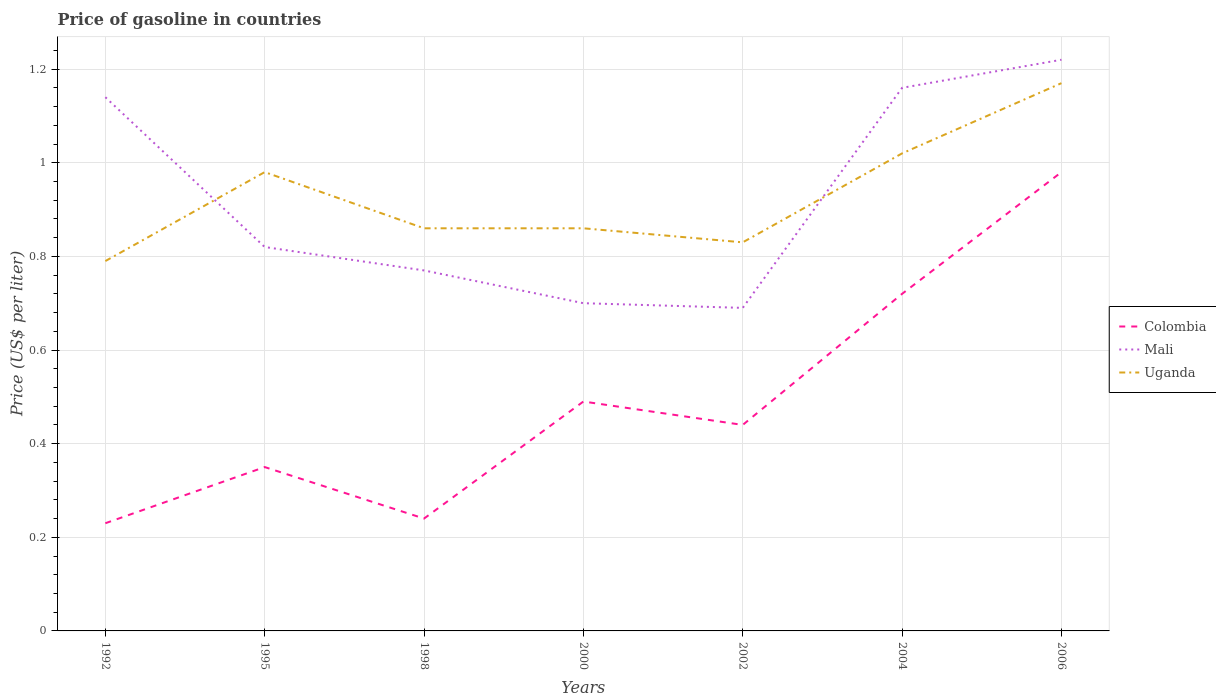How many different coloured lines are there?
Your answer should be compact. 3. Does the line corresponding to Colombia intersect with the line corresponding to Mali?
Your answer should be very brief. No. Is the number of lines equal to the number of legend labels?
Offer a terse response. Yes. Across all years, what is the maximum price of gasoline in Mali?
Offer a very short reply. 0.69. What is the total price of gasoline in Uganda in the graph?
Provide a succinct answer. -0.07. What is the difference between the highest and the second highest price of gasoline in Uganda?
Provide a short and direct response. 0.38. What is the difference between the highest and the lowest price of gasoline in Colombia?
Provide a succinct answer. 2. How many lines are there?
Provide a succinct answer. 3. Does the graph contain any zero values?
Offer a terse response. No. Where does the legend appear in the graph?
Provide a succinct answer. Center right. How are the legend labels stacked?
Make the answer very short. Vertical. What is the title of the graph?
Provide a succinct answer. Price of gasoline in countries. Does "Papua New Guinea" appear as one of the legend labels in the graph?
Ensure brevity in your answer.  No. What is the label or title of the Y-axis?
Ensure brevity in your answer.  Price (US$ per liter). What is the Price (US$ per liter) in Colombia in 1992?
Ensure brevity in your answer.  0.23. What is the Price (US$ per liter) in Mali in 1992?
Your response must be concise. 1.14. What is the Price (US$ per liter) in Uganda in 1992?
Your response must be concise. 0.79. What is the Price (US$ per liter) in Mali in 1995?
Keep it short and to the point. 0.82. What is the Price (US$ per liter) of Colombia in 1998?
Your answer should be very brief. 0.24. What is the Price (US$ per liter) of Mali in 1998?
Ensure brevity in your answer.  0.77. What is the Price (US$ per liter) in Uganda in 1998?
Offer a terse response. 0.86. What is the Price (US$ per liter) of Colombia in 2000?
Offer a terse response. 0.49. What is the Price (US$ per liter) in Uganda in 2000?
Offer a terse response. 0.86. What is the Price (US$ per liter) in Colombia in 2002?
Keep it short and to the point. 0.44. What is the Price (US$ per liter) of Mali in 2002?
Your response must be concise. 0.69. What is the Price (US$ per liter) in Uganda in 2002?
Your response must be concise. 0.83. What is the Price (US$ per liter) in Colombia in 2004?
Make the answer very short. 0.72. What is the Price (US$ per liter) in Mali in 2004?
Make the answer very short. 1.16. What is the Price (US$ per liter) of Uganda in 2004?
Offer a terse response. 1.02. What is the Price (US$ per liter) in Mali in 2006?
Give a very brief answer. 1.22. What is the Price (US$ per liter) in Uganda in 2006?
Provide a short and direct response. 1.17. Across all years, what is the maximum Price (US$ per liter) in Mali?
Keep it short and to the point. 1.22. Across all years, what is the maximum Price (US$ per liter) in Uganda?
Give a very brief answer. 1.17. Across all years, what is the minimum Price (US$ per liter) of Colombia?
Your answer should be compact. 0.23. Across all years, what is the minimum Price (US$ per liter) of Mali?
Your answer should be compact. 0.69. Across all years, what is the minimum Price (US$ per liter) in Uganda?
Your response must be concise. 0.79. What is the total Price (US$ per liter) in Colombia in the graph?
Give a very brief answer. 3.45. What is the total Price (US$ per liter) of Mali in the graph?
Offer a terse response. 6.5. What is the total Price (US$ per liter) of Uganda in the graph?
Offer a terse response. 6.51. What is the difference between the Price (US$ per liter) of Colombia in 1992 and that in 1995?
Your response must be concise. -0.12. What is the difference between the Price (US$ per liter) in Mali in 1992 and that in 1995?
Keep it short and to the point. 0.32. What is the difference between the Price (US$ per liter) in Uganda in 1992 and that in 1995?
Offer a terse response. -0.19. What is the difference between the Price (US$ per liter) of Colombia in 1992 and that in 1998?
Provide a succinct answer. -0.01. What is the difference between the Price (US$ per liter) of Mali in 1992 and that in 1998?
Provide a short and direct response. 0.37. What is the difference between the Price (US$ per liter) of Uganda in 1992 and that in 1998?
Provide a short and direct response. -0.07. What is the difference between the Price (US$ per liter) of Colombia in 1992 and that in 2000?
Make the answer very short. -0.26. What is the difference between the Price (US$ per liter) in Mali in 1992 and that in 2000?
Make the answer very short. 0.44. What is the difference between the Price (US$ per liter) in Uganda in 1992 and that in 2000?
Your response must be concise. -0.07. What is the difference between the Price (US$ per liter) in Colombia in 1992 and that in 2002?
Your answer should be compact. -0.21. What is the difference between the Price (US$ per liter) in Mali in 1992 and that in 2002?
Give a very brief answer. 0.45. What is the difference between the Price (US$ per liter) of Uganda in 1992 and that in 2002?
Provide a succinct answer. -0.04. What is the difference between the Price (US$ per liter) of Colombia in 1992 and that in 2004?
Ensure brevity in your answer.  -0.49. What is the difference between the Price (US$ per liter) in Mali in 1992 and that in 2004?
Provide a short and direct response. -0.02. What is the difference between the Price (US$ per liter) of Uganda in 1992 and that in 2004?
Your answer should be very brief. -0.23. What is the difference between the Price (US$ per liter) of Colombia in 1992 and that in 2006?
Make the answer very short. -0.75. What is the difference between the Price (US$ per liter) of Mali in 1992 and that in 2006?
Ensure brevity in your answer.  -0.08. What is the difference between the Price (US$ per liter) of Uganda in 1992 and that in 2006?
Give a very brief answer. -0.38. What is the difference between the Price (US$ per liter) in Colombia in 1995 and that in 1998?
Ensure brevity in your answer.  0.11. What is the difference between the Price (US$ per liter) in Mali in 1995 and that in 1998?
Offer a very short reply. 0.05. What is the difference between the Price (US$ per liter) in Uganda in 1995 and that in 1998?
Offer a very short reply. 0.12. What is the difference between the Price (US$ per liter) of Colombia in 1995 and that in 2000?
Offer a terse response. -0.14. What is the difference between the Price (US$ per liter) in Mali in 1995 and that in 2000?
Offer a very short reply. 0.12. What is the difference between the Price (US$ per liter) in Uganda in 1995 and that in 2000?
Keep it short and to the point. 0.12. What is the difference between the Price (US$ per liter) of Colombia in 1995 and that in 2002?
Your response must be concise. -0.09. What is the difference between the Price (US$ per liter) in Mali in 1995 and that in 2002?
Make the answer very short. 0.13. What is the difference between the Price (US$ per liter) of Colombia in 1995 and that in 2004?
Provide a succinct answer. -0.37. What is the difference between the Price (US$ per liter) in Mali in 1995 and that in 2004?
Provide a succinct answer. -0.34. What is the difference between the Price (US$ per liter) in Uganda in 1995 and that in 2004?
Provide a short and direct response. -0.04. What is the difference between the Price (US$ per liter) of Colombia in 1995 and that in 2006?
Give a very brief answer. -0.63. What is the difference between the Price (US$ per liter) of Mali in 1995 and that in 2006?
Make the answer very short. -0.4. What is the difference between the Price (US$ per liter) in Uganda in 1995 and that in 2006?
Ensure brevity in your answer.  -0.19. What is the difference between the Price (US$ per liter) in Mali in 1998 and that in 2000?
Provide a short and direct response. 0.07. What is the difference between the Price (US$ per liter) in Uganda in 1998 and that in 2000?
Provide a short and direct response. 0. What is the difference between the Price (US$ per liter) in Colombia in 1998 and that in 2002?
Keep it short and to the point. -0.2. What is the difference between the Price (US$ per liter) of Mali in 1998 and that in 2002?
Offer a very short reply. 0.08. What is the difference between the Price (US$ per liter) of Colombia in 1998 and that in 2004?
Your answer should be compact. -0.48. What is the difference between the Price (US$ per liter) in Mali in 1998 and that in 2004?
Make the answer very short. -0.39. What is the difference between the Price (US$ per liter) in Uganda in 1998 and that in 2004?
Keep it short and to the point. -0.16. What is the difference between the Price (US$ per liter) in Colombia in 1998 and that in 2006?
Give a very brief answer. -0.74. What is the difference between the Price (US$ per liter) in Mali in 1998 and that in 2006?
Provide a short and direct response. -0.45. What is the difference between the Price (US$ per liter) of Uganda in 1998 and that in 2006?
Offer a terse response. -0.31. What is the difference between the Price (US$ per liter) of Colombia in 2000 and that in 2002?
Provide a succinct answer. 0.05. What is the difference between the Price (US$ per liter) of Uganda in 2000 and that in 2002?
Provide a short and direct response. 0.03. What is the difference between the Price (US$ per liter) of Colombia in 2000 and that in 2004?
Provide a short and direct response. -0.23. What is the difference between the Price (US$ per liter) of Mali in 2000 and that in 2004?
Ensure brevity in your answer.  -0.46. What is the difference between the Price (US$ per liter) of Uganda in 2000 and that in 2004?
Your response must be concise. -0.16. What is the difference between the Price (US$ per liter) in Colombia in 2000 and that in 2006?
Provide a succinct answer. -0.49. What is the difference between the Price (US$ per liter) of Mali in 2000 and that in 2006?
Keep it short and to the point. -0.52. What is the difference between the Price (US$ per liter) in Uganda in 2000 and that in 2006?
Give a very brief answer. -0.31. What is the difference between the Price (US$ per liter) in Colombia in 2002 and that in 2004?
Ensure brevity in your answer.  -0.28. What is the difference between the Price (US$ per liter) in Mali in 2002 and that in 2004?
Offer a terse response. -0.47. What is the difference between the Price (US$ per liter) in Uganda in 2002 and that in 2004?
Give a very brief answer. -0.19. What is the difference between the Price (US$ per liter) in Colombia in 2002 and that in 2006?
Your answer should be very brief. -0.54. What is the difference between the Price (US$ per liter) of Mali in 2002 and that in 2006?
Provide a succinct answer. -0.53. What is the difference between the Price (US$ per liter) of Uganda in 2002 and that in 2006?
Offer a very short reply. -0.34. What is the difference between the Price (US$ per liter) of Colombia in 2004 and that in 2006?
Offer a terse response. -0.26. What is the difference between the Price (US$ per liter) in Mali in 2004 and that in 2006?
Provide a short and direct response. -0.06. What is the difference between the Price (US$ per liter) of Uganda in 2004 and that in 2006?
Provide a succinct answer. -0.15. What is the difference between the Price (US$ per liter) of Colombia in 1992 and the Price (US$ per liter) of Mali in 1995?
Your answer should be compact. -0.59. What is the difference between the Price (US$ per liter) in Colombia in 1992 and the Price (US$ per liter) in Uganda in 1995?
Keep it short and to the point. -0.75. What is the difference between the Price (US$ per liter) in Mali in 1992 and the Price (US$ per liter) in Uganda in 1995?
Provide a short and direct response. 0.16. What is the difference between the Price (US$ per liter) of Colombia in 1992 and the Price (US$ per liter) of Mali in 1998?
Keep it short and to the point. -0.54. What is the difference between the Price (US$ per liter) in Colombia in 1992 and the Price (US$ per liter) in Uganda in 1998?
Give a very brief answer. -0.63. What is the difference between the Price (US$ per liter) of Mali in 1992 and the Price (US$ per liter) of Uganda in 1998?
Ensure brevity in your answer.  0.28. What is the difference between the Price (US$ per liter) in Colombia in 1992 and the Price (US$ per liter) in Mali in 2000?
Give a very brief answer. -0.47. What is the difference between the Price (US$ per liter) in Colombia in 1992 and the Price (US$ per liter) in Uganda in 2000?
Your response must be concise. -0.63. What is the difference between the Price (US$ per liter) of Mali in 1992 and the Price (US$ per liter) of Uganda in 2000?
Provide a succinct answer. 0.28. What is the difference between the Price (US$ per liter) in Colombia in 1992 and the Price (US$ per liter) in Mali in 2002?
Your response must be concise. -0.46. What is the difference between the Price (US$ per liter) of Mali in 1992 and the Price (US$ per liter) of Uganda in 2002?
Give a very brief answer. 0.31. What is the difference between the Price (US$ per liter) in Colombia in 1992 and the Price (US$ per liter) in Mali in 2004?
Offer a terse response. -0.93. What is the difference between the Price (US$ per liter) in Colombia in 1992 and the Price (US$ per liter) in Uganda in 2004?
Your response must be concise. -0.79. What is the difference between the Price (US$ per liter) of Mali in 1992 and the Price (US$ per liter) of Uganda in 2004?
Your answer should be very brief. 0.12. What is the difference between the Price (US$ per liter) in Colombia in 1992 and the Price (US$ per liter) in Mali in 2006?
Give a very brief answer. -0.99. What is the difference between the Price (US$ per liter) of Colombia in 1992 and the Price (US$ per liter) of Uganda in 2006?
Your answer should be very brief. -0.94. What is the difference between the Price (US$ per liter) in Mali in 1992 and the Price (US$ per liter) in Uganda in 2006?
Make the answer very short. -0.03. What is the difference between the Price (US$ per liter) of Colombia in 1995 and the Price (US$ per liter) of Mali in 1998?
Offer a very short reply. -0.42. What is the difference between the Price (US$ per liter) of Colombia in 1995 and the Price (US$ per liter) of Uganda in 1998?
Provide a succinct answer. -0.51. What is the difference between the Price (US$ per liter) in Mali in 1995 and the Price (US$ per liter) in Uganda in 1998?
Ensure brevity in your answer.  -0.04. What is the difference between the Price (US$ per liter) of Colombia in 1995 and the Price (US$ per liter) of Mali in 2000?
Provide a short and direct response. -0.35. What is the difference between the Price (US$ per liter) of Colombia in 1995 and the Price (US$ per liter) of Uganda in 2000?
Provide a short and direct response. -0.51. What is the difference between the Price (US$ per liter) in Mali in 1995 and the Price (US$ per liter) in Uganda in 2000?
Ensure brevity in your answer.  -0.04. What is the difference between the Price (US$ per liter) in Colombia in 1995 and the Price (US$ per liter) in Mali in 2002?
Provide a succinct answer. -0.34. What is the difference between the Price (US$ per liter) of Colombia in 1995 and the Price (US$ per liter) of Uganda in 2002?
Offer a very short reply. -0.48. What is the difference between the Price (US$ per liter) of Mali in 1995 and the Price (US$ per liter) of Uganda in 2002?
Keep it short and to the point. -0.01. What is the difference between the Price (US$ per liter) of Colombia in 1995 and the Price (US$ per liter) of Mali in 2004?
Give a very brief answer. -0.81. What is the difference between the Price (US$ per liter) of Colombia in 1995 and the Price (US$ per liter) of Uganda in 2004?
Your answer should be compact. -0.67. What is the difference between the Price (US$ per liter) in Mali in 1995 and the Price (US$ per liter) in Uganda in 2004?
Your answer should be compact. -0.2. What is the difference between the Price (US$ per liter) of Colombia in 1995 and the Price (US$ per liter) of Mali in 2006?
Provide a succinct answer. -0.87. What is the difference between the Price (US$ per liter) of Colombia in 1995 and the Price (US$ per liter) of Uganda in 2006?
Your answer should be very brief. -0.82. What is the difference between the Price (US$ per liter) of Mali in 1995 and the Price (US$ per liter) of Uganda in 2006?
Provide a succinct answer. -0.35. What is the difference between the Price (US$ per liter) in Colombia in 1998 and the Price (US$ per liter) in Mali in 2000?
Make the answer very short. -0.46. What is the difference between the Price (US$ per liter) of Colombia in 1998 and the Price (US$ per liter) of Uganda in 2000?
Provide a succinct answer. -0.62. What is the difference between the Price (US$ per liter) in Mali in 1998 and the Price (US$ per liter) in Uganda in 2000?
Offer a terse response. -0.09. What is the difference between the Price (US$ per liter) of Colombia in 1998 and the Price (US$ per liter) of Mali in 2002?
Your answer should be compact. -0.45. What is the difference between the Price (US$ per liter) of Colombia in 1998 and the Price (US$ per liter) of Uganda in 2002?
Your response must be concise. -0.59. What is the difference between the Price (US$ per liter) in Mali in 1998 and the Price (US$ per liter) in Uganda in 2002?
Offer a very short reply. -0.06. What is the difference between the Price (US$ per liter) of Colombia in 1998 and the Price (US$ per liter) of Mali in 2004?
Your answer should be very brief. -0.92. What is the difference between the Price (US$ per liter) of Colombia in 1998 and the Price (US$ per liter) of Uganda in 2004?
Ensure brevity in your answer.  -0.78. What is the difference between the Price (US$ per liter) in Colombia in 1998 and the Price (US$ per liter) in Mali in 2006?
Make the answer very short. -0.98. What is the difference between the Price (US$ per liter) of Colombia in 1998 and the Price (US$ per liter) of Uganda in 2006?
Your response must be concise. -0.93. What is the difference between the Price (US$ per liter) of Colombia in 2000 and the Price (US$ per liter) of Mali in 2002?
Offer a very short reply. -0.2. What is the difference between the Price (US$ per liter) of Colombia in 2000 and the Price (US$ per liter) of Uganda in 2002?
Ensure brevity in your answer.  -0.34. What is the difference between the Price (US$ per liter) in Mali in 2000 and the Price (US$ per liter) in Uganda in 2002?
Keep it short and to the point. -0.13. What is the difference between the Price (US$ per liter) of Colombia in 2000 and the Price (US$ per liter) of Mali in 2004?
Provide a short and direct response. -0.67. What is the difference between the Price (US$ per liter) in Colombia in 2000 and the Price (US$ per liter) in Uganda in 2004?
Keep it short and to the point. -0.53. What is the difference between the Price (US$ per liter) of Mali in 2000 and the Price (US$ per liter) of Uganda in 2004?
Provide a succinct answer. -0.32. What is the difference between the Price (US$ per liter) of Colombia in 2000 and the Price (US$ per liter) of Mali in 2006?
Offer a terse response. -0.73. What is the difference between the Price (US$ per liter) in Colombia in 2000 and the Price (US$ per liter) in Uganda in 2006?
Ensure brevity in your answer.  -0.68. What is the difference between the Price (US$ per liter) in Mali in 2000 and the Price (US$ per liter) in Uganda in 2006?
Keep it short and to the point. -0.47. What is the difference between the Price (US$ per liter) in Colombia in 2002 and the Price (US$ per liter) in Mali in 2004?
Your answer should be very brief. -0.72. What is the difference between the Price (US$ per liter) in Colombia in 2002 and the Price (US$ per liter) in Uganda in 2004?
Offer a terse response. -0.58. What is the difference between the Price (US$ per liter) of Mali in 2002 and the Price (US$ per liter) of Uganda in 2004?
Provide a short and direct response. -0.33. What is the difference between the Price (US$ per liter) in Colombia in 2002 and the Price (US$ per liter) in Mali in 2006?
Ensure brevity in your answer.  -0.78. What is the difference between the Price (US$ per liter) of Colombia in 2002 and the Price (US$ per liter) of Uganda in 2006?
Keep it short and to the point. -0.73. What is the difference between the Price (US$ per liter) in Mali in 2002 and the Price (US$ per liter) in Uganda in 2006?
Provide a succinct answer. -0.48. What is the difference between the Price (US$ per liter) in Colombia in 2004 and the Price (US$ per liter) in Uganda in 2006?
Provide a succinct answer. -0.45. What is the difference between the Price (US$ per liter) in Mali in 2004 and the Price (US$ per liter) in Uganda in 2006?
Your answer should be compact. -0.01. What is the average Price (US$ per liter) of Colombia per year?
Offer a terse response. 0.49. What is the average Price (US$ per liter) of Uganda per year?
Offer a very short reply. 0.93. In the year 1992, what is the difference between the Price (US$ per liter) in Colombia and Price (US$ per liter) in Mali?
Make the answer very short. -0.91. In the year 1992, what is the difference between the Price (US$ per liter) in Colombia and Price (US$ per liter) in Uganda?
Keep it short and to the point. -0.56. In the year 1995, what is the difference between the Price (US$ per liter) in Colombia and Price (US$ per liter) in Mali?
Make the answer very short. -0.47. In the year 1995, what is the difference between the Price (US$ per liter) in Colombia and Price (US$ per liter) in Uganda?
Provide a short and direct response. -0.63. In the year 1995, what is the difference between the Price (US$ per liter) of Mali and Price (US$ per liter) of Uganda?
Keep it short and to the point. -0.16. In the year 1998, what is the difference between the Price (US$ per liter) in Colombia and Price (US$ per liter) in Mali?
Give a very brief answer. -0.53. In the year 1998, what is the difference between the Price (US$ per liter) in Colombia and Price (US$ per liter) in Uganda?
Provide a short and direct response. -0.62. In the year 1998, what is the difference between the Price (US$ per liter) of Mali and Price (US$ per liter) of Uganda?
Offer a very short reply. -0.09. In the year 2000, what is the difference between the Price (US$ per liter) in Colombia and Price (US$ per liter) in Mali?
Offer a very short reply. -0.21. In the year 2000, what is the difference between the Price (US$ per liter) in Colombia and Price (US$ per liter) in Uganda?
Offer a terse response. -0.37. In the year 2000, what is the difference between the Price (US$ per liter) of Mali and Price (US$ per liter) of Uganda?
Your answer should be very brief. -0.16. In the year 2002, what is the difference between the Price (US$ per liter) in Colombia and Price (US$ per liter) in Mali?
Give a very brief answer. -0.25. In the year 2002, what is the difference between the Price (US$ per liter) in Colombia and Price (US$ per liter) in Uganda?
Your answer should be very brief. -0.39. In the year 2002, what is the difference between the Price (US$ per liter) in Mali and Price (US$ per liter) in Uganda?
Keep it short and to the point. -0.14. In the year 2004, what is the difference between the Price (US$ per liter) in Colombia and Price (US$ per liter) in Mali?
Provide a short and direct response. -0.44. In the year 2004, what is the difference between the Price (US$ per liter) of Colombia and Price (US$ per liter) of Uganda?
Offer a very short reply. -0.3. In the year 2004, what is the difference between the Price (US$ per liter) of Mali and Price (US$ per liter) of Uganda?
Your answer should be very brief. 0.14. In the year 2006, what is the difference between the Price (US$ per liter) in Colombia and Price (US$ per liter) in Mali?
Keep it short and to the point. -0.24. In the year 2006, what is the difference between the Price (US$ per liter) in Colombia and Price (US$ per liter) in Uganda?
Provide a short and direct response. -0.19. In the year 2006, what is the difference between the Price (US$ per liter) of Mali and Price (US$ per liter) of Uganda?
Your answer should be compact. 0.05. What is the ratio of the Price (US$ per liter) in Colombia in 1992 to that in 1995?
Keep it short and to the point. 0.66. What is the ratio of the Price (US$ per liter) in Mali in 1992 to that in 1995?
Provide a short and direct response. 1.39. What is the ratio of the Price (US$ per liter) in Uganda in 1992 to that in 1995?
Your answer should be very brief. 0.81. What is the ratio of the Price (US$ per liter) in Mali in 1992 to that in 1998?
Keep it short and to the point. 1.48. What is the ratio of the Price (US$ per liter) of Uganda in 1992 to that in 1998?
Your answer should be compact. 0.92. What is the ratio of the Price (US$ per liter) of Colombia in 1992 to that in 2000?
Your answer should be compact. 0.47. What is the ratio of the Price (US$ per liter) in Mali in 1992 to that in 2000?
Your response must be concise. 1.63. What is the ratio of the Price (US$ per liter) of Uganda in 1992 to that in 2000?
Your answer should be compact. 0.92. What is the ratio of the Price (US$ per liter) of Colombia in 1992 to that in 2002?
Your response must be concise. 0.52. What is the ratio of the Price (US$ per liter) of Mali in 1992 to that in 2002?
Keep it short and to the point. 1.65. What is the ratio of the Price (US$ per liter) of Uganda in 1992 to that in 2002?
Give a very brief answer. 0.95. What is the ratio of the Price (US$ per liter) in Colombia in 1992 to that in 2004?
Ensure brevity in your answer.  0.32. What is the ratio of the Price (US$ per liter) in Mali in 1992 to that in 2004?
Offer a terse response. 0.98. What is the ratio of the Price (US$ per liter) of Uganda in 1992 to that in 2004?
Give a very brief answer. 0.77. What is the ratio of the Price (US$ per liter) in Colombia in 1992 to that in 2006?
Provide a succinct answer. 0.23. What is the ratio of the Price (US$ per liter) in Mali in 1992 to that in 2006?
Your answer should be very brief. 0.93. What is the ratio of the Price (US$ per liter) in Uganda in 1992 to that in 2006?
Offer a very short reply. 0.68. What is the ratio of the Price (US$ per liter) in Colombia in 1995 to that in 1998?
Provide a succinct answer. 1.46. What is the ratio of the Price (US$ per liter) of Mali in 1995 to that in 1998?
Provide a succinct answer. 1.06. What is the ratio of the Price (US$ per liter) in Uganda in 1995 to that in 1998?
Your answer should be compact. 1.14. What is the ratio of the Price (US$ per liter) in Mali in 1995 to that in 2000?
Your response must be concise. 1.17. What is the ratio of the Price (US$ per liter) of Uganda in 1995 to that in 2000?
Give a very brief answer. 1.14. What is the ratio of the Price (US$ per liter) of Colombia in 1995 to that in 2002?
Ensure brevity in your answer.  0.8. What is the ratio of the Price (US$ per liter) in Mali in 1995 to that in 2002?
Make the answer very short. 1.19. What is the ratio of the Price (US$ per liter) in Uganda in 1995 to that in 2002?
Keep it short and to the point. 1.18. What is the ratio of the Price (US$ per liter) in Colombia in 1995 to that in 2004?
Your answer should be very brief. 0.49. What is the ratio of the Price (US$ per liter) of Mali in 1995 to that in 2004?
Give a very brief answer. 0.71. What is the ratio of the Price (US$ per liter) of Uganda in 1995 to that in 2004?
Ensure brevity in your answer.  0.96. What is the ratio of the Price (US$ per liter) of Colombia in 1995 to that in 2006?
Ensure brevity in your answer.  0.36. What is the ratio of the Price (US$ per liter) in Mali in 1995 to that in 2006?
Keep it short and to the point. 0.67. What is the ratio of the Price (US$ per liter) in Uganda in 1995 to that in 2006?
Provide a succinct answer. 0.84. What is the ratio of the Price (US$ per liter) of Colombia in 1998 to that in 2000?
Make the answer very short. 0.49. What is the ratio of the Price (US$ per liter) in Colombia in 1998 to that in 2002?
Ensure brevity in your answer.  0.55. What is the ratio of the Price (US$ per liter) of Mali in 1998 to that in 2002?
Keep it short and to the point. 1.12. What is the ratio of the Price (US$ per liter) in Uganda in 1998 to that in 2002?
Keep it short and to the point. 1.04. What is the ratio of the Price (US$ per liter) in Colombia in 1998 to that in 2004?
Keep it short and to the point. 0.33. What is the ratio of the Price (US$ per liter) of Mali in 1998 to that in 2004?
Give a very brief answer. 0.66. What is the ratio of the Price (US$ per liter) of Uganda in 1998 to that in 2004?
Offer a terse response. 0.84. What is the ratio of the Price (US$ per liter) in Colombia in 1998 to that in 2006?
Ensure brevity in your answer.  0.24. What is the ratio of the Price (US$ per liter) in Mali in 1998 to that in 2006?
Make the answer very short. 0.63. What is the ratio of the Price (US$ per liter) of Uganda in 1998 to that in 2006?
Ensure brevity in your answer.  0.73. What is the ratio of the Price (US$ per liter) in Colombia in 2000 to that in 2002?
Give a very brief answer. 1.11. What is the ratio of the Price (US$ per liter) in Mali in 2000 to that in 2002?
Offer a very short reply. 1.01. What is the ratio of the Price (US$ per liter) of Uganda in 2000 to that in 2002?
Offer a terse response. 1.04. What is the ratio of the Price (US$ per liter) of Colombia in 2000 to that in 2004?
Your answer should be compact. 0.68. What is the ratio of the Price (US$ per liter) in Mali in 2000 to that in 2004?
Give a very brief answer. 0.6. What is the ratio of the Price (US$ per liter) of Uganda in 2000 to that in 2004?
Your answer should be very brief. 0.84. What is the ratio of the Price (US$ per liter) in Colombia in 2000 to that in 2006?
Give a very brief answer. 0.5. What is the ratio of the Price (US$ per liter) in Mali in 2000 to that in 2006?
Keep it short and to the point. 0.57. What is the ratio of the Price (US$ per liter) of Uganda in 2000 to that in 2006?
Your response must be concise. 0.73. What is the ratio of the Price (US$ per liter) of Colombia in 2002 to that in 2004?
Provide a short and direct response. 0.61. What is the ratio of the Price (US$ per liter) in Mali in 2002 to that in 2004?
Your answer should be compact. 0.59. What is the ratio of the Price (US$ per liter) in Uganda in 2002 to that in 2004?
Your response must be concise. 0.81. What is the ratio of the Price (US$ per liter) in Colombia in 2002 to that in 2006?
Your answer should be very brief. 0.45. What is the ratio of the Price (US$ per liter) in Mali in 2002 to that in 2006?
Make the answer very short. 0.57. What is the ratio of the Price (US$ per liter) of Uganda in 2002 to that in 2006?
Offer a terse response. 0.71. What is the ratio of the Price (US$ per liter) of Colombia in 2004 to that in 2006?
Your response must be concise. 0.73. What is the ratio of the Price (US$ per liter) in Mali in 2004 to that in 2006?
Your answer should be very brief. 0.95. What is the ratio of the Price (US$ per liter) of Uganda in 2004 to that in 2006?
Your answer should be very brief. 0.87. What is the difference between the highest and the second highest Price (US$ per liter) of Colombia?
Provide a succinct answer. 0.26. What is the difference between the highest and the lowest Price (US$ per liter) in Mali?
Give a very brief answer. 0.53. What is the difference between the highest and the lowest Price (US$ per liter) in Uganda?
Ensure brevity in your answer.  0.38. 